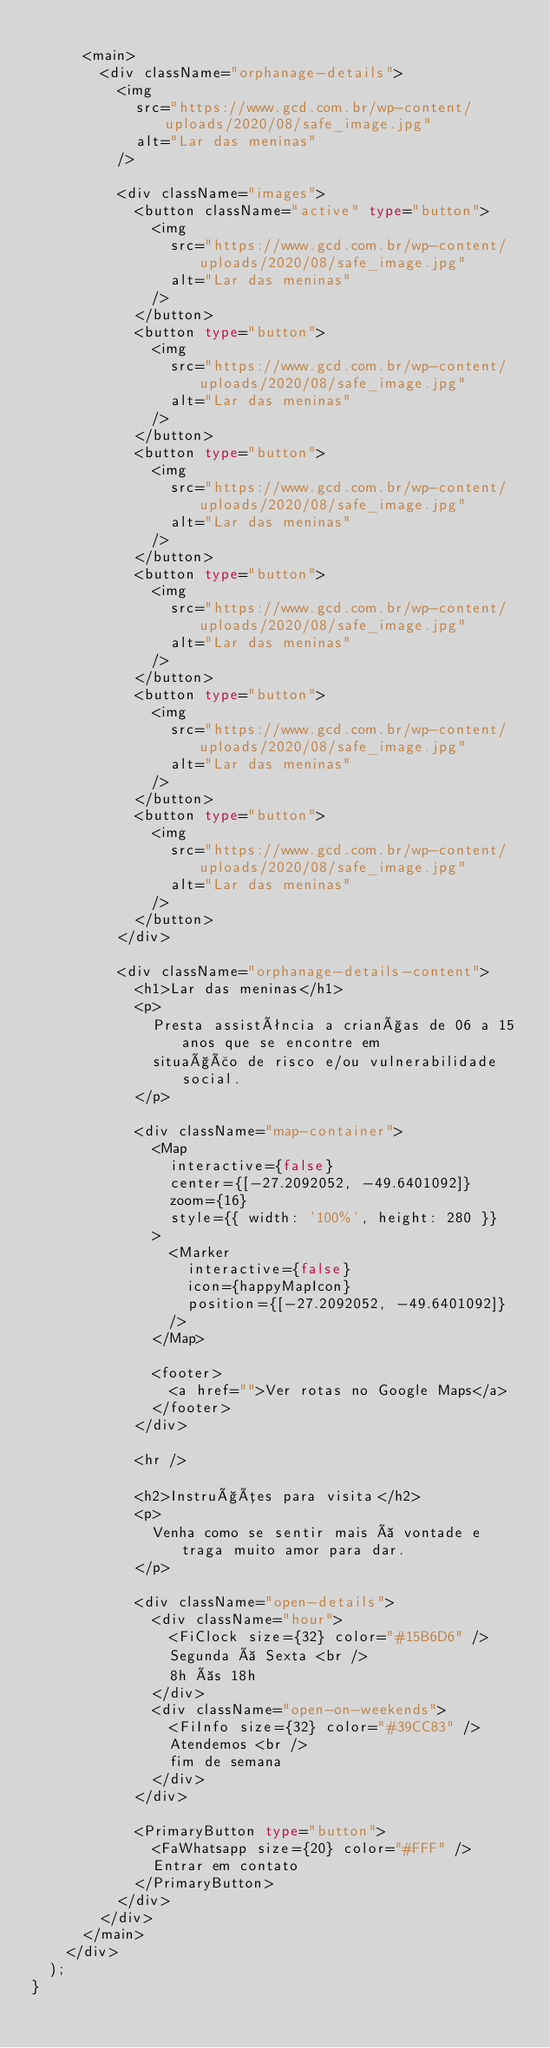Convert code to text. <code><loc_0><loc_0><loc_500><loc_500><_TypeScript_>
      <main>
        <div className="orphanage-details">
          <img
            src="https://www.gcd.com.br/wp-content/uploads/2020/08/safe_image.jpg"
            alt="Lar das meninas"
          />

          <div className="images">
            <button className="active" type="button">
              <img
                src="https://www.gcd.com.br/wp-content/uploads/2020/08/safe_image.jpg"
                alt="Lar das meninas"
              />
            </button>
            <button type="button">
              <img
                src="https://www.gcd.com.br/wp-content/uploads/2020/08/safe_image.jpg"
                alt="Lar das meninas"
              />
            </button>
            <button type="button">
              <img
                src="https://www.gcd.com.br/wp-content/uploads/2020/08/safe_image.jpg"
                alt="Lar das meninas"
              />
            </button>
            <button type="button">
              <img
                src="https://www.gcd.com.br/wp-content/uploads/2020/08/safe_image.jpg"
                alt="Lar das meninas"
              />
            </button>
            <button type="button">
              <img
                src="https://www.gcd.com.br/wp-content/uploads/2020/08/safe_image.jpg"
                alt="Lar das meninas"
              />
            </button>
            <button type="button">
              <img
                src="https://www.gcd.com.br/wp-content/uploads/2020/08/safe_image.jpg"
                alt="Lar das meninas"
              />
            </button>
          </div>

          <div className="orphanage-details-content">
            <h1>Lar das meninas</h1>
            <p>
              Presta assistência a crianças de 06 a 15 anos que se encontre em
              situação de risco e/ou vulnerabilidade social.
            </p>

            <div className="map-container">
              <Map
                interactive={false}
                center={[-27.2092052, -49.6401092]}
                zoom={16}
                style={{ width: '100%', height: 280 }}
              >
                <Marker
                  interactive={false}
                  icon={happyMapIcon}
                  position={[-27.2092052, -49.6401092]}
                />
              </Map>

              <footer>
                <a href="">Ver rotas no Google Maps</a>
              </footer>
            </div>

            <hr />

            <h2>Instruções para visita</h2>
            <p>
              Venha como se sentir mais à vontade e traga muito amor para dar.
            </p>

            <div className="open-details">
              <div className="hour">
                <FiClock size={32} color="#15B6D6" />
                Segunda à Sexta <br />
                8h às 18h
              </div>
              <div className="open-on-weekends">
                <FiInfo size={32} color="#39CC83" />
                Atendemos <br />
                fim de semana
              </div>
            </div>

            <PrimaryButton type="button">
              <FaWhatsapp size={20} color="#FFF" />
              Entrar em contato
            </PrimaryButton>
          </div>
        </div>
      </main>
    </div>
  );
}
</code> 